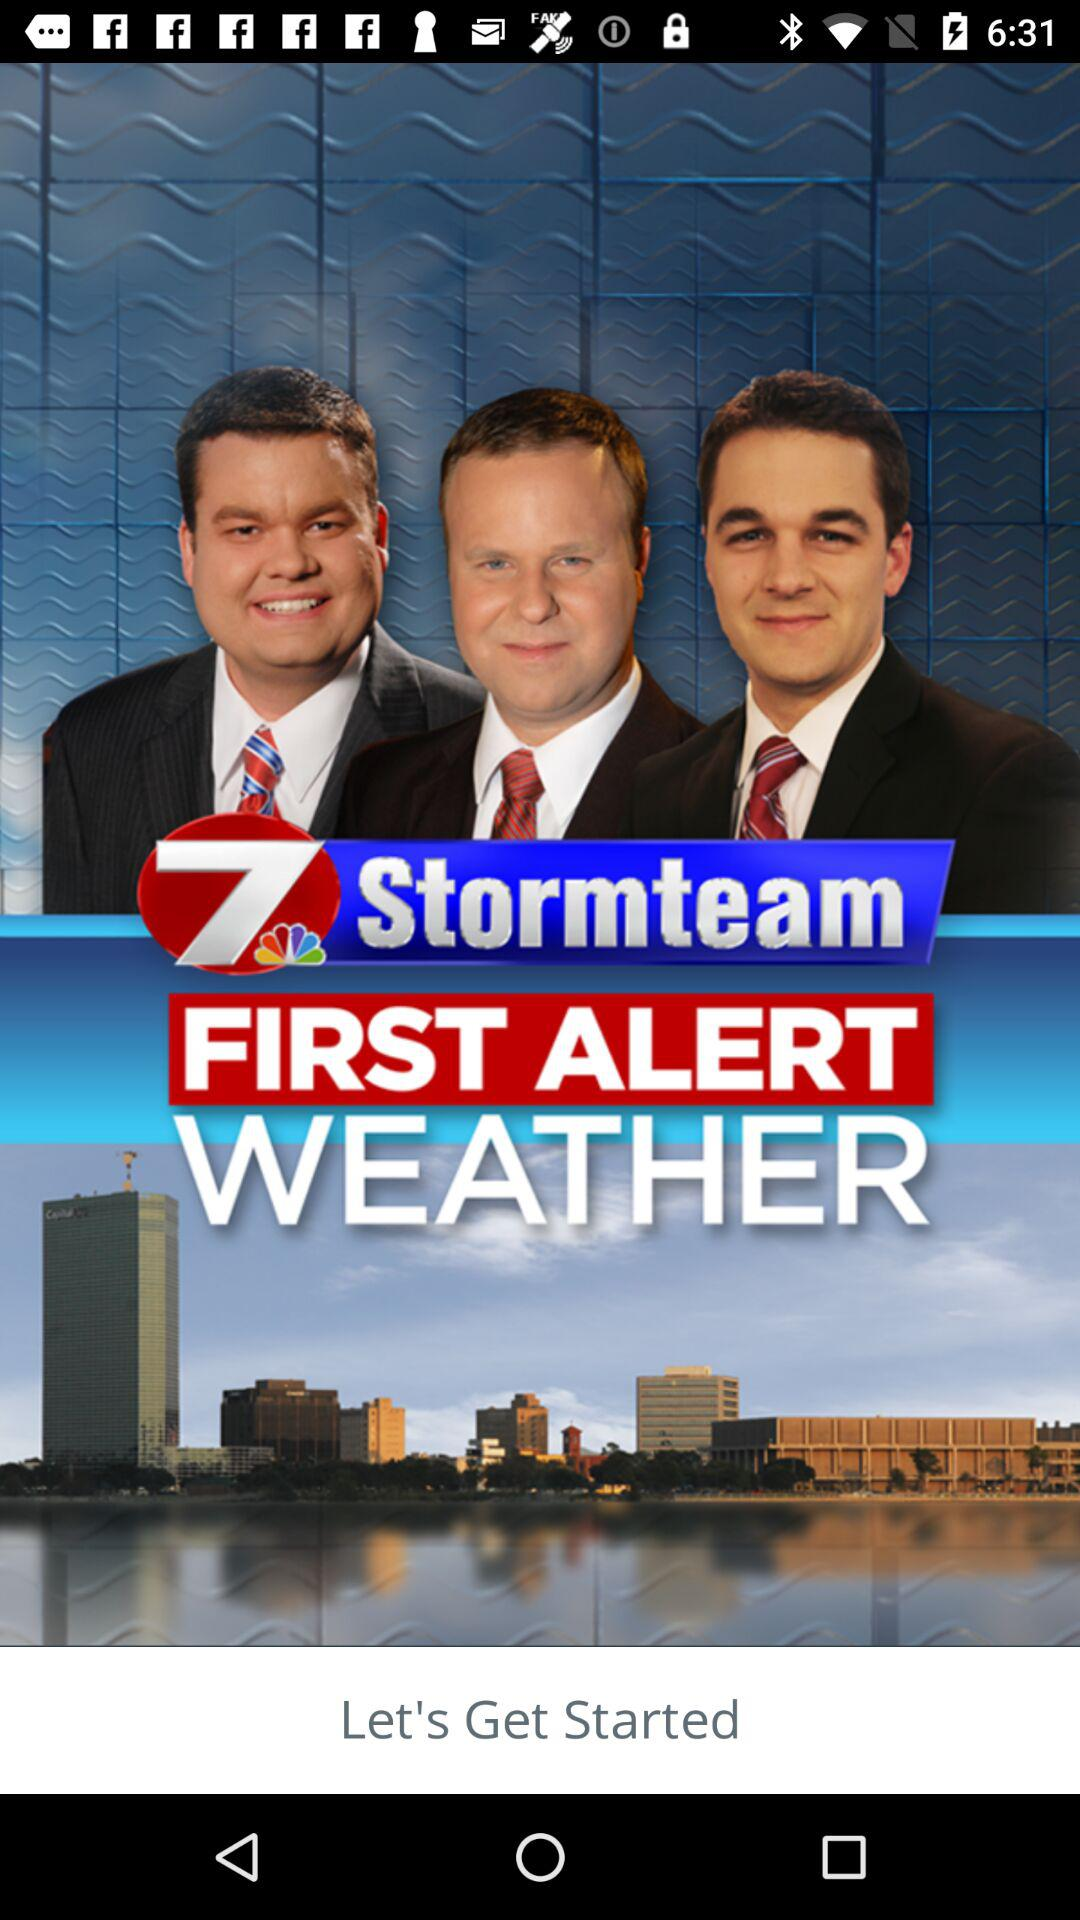What is the name of the application? The name of the application is "FIRST ALERT WEATHER". 